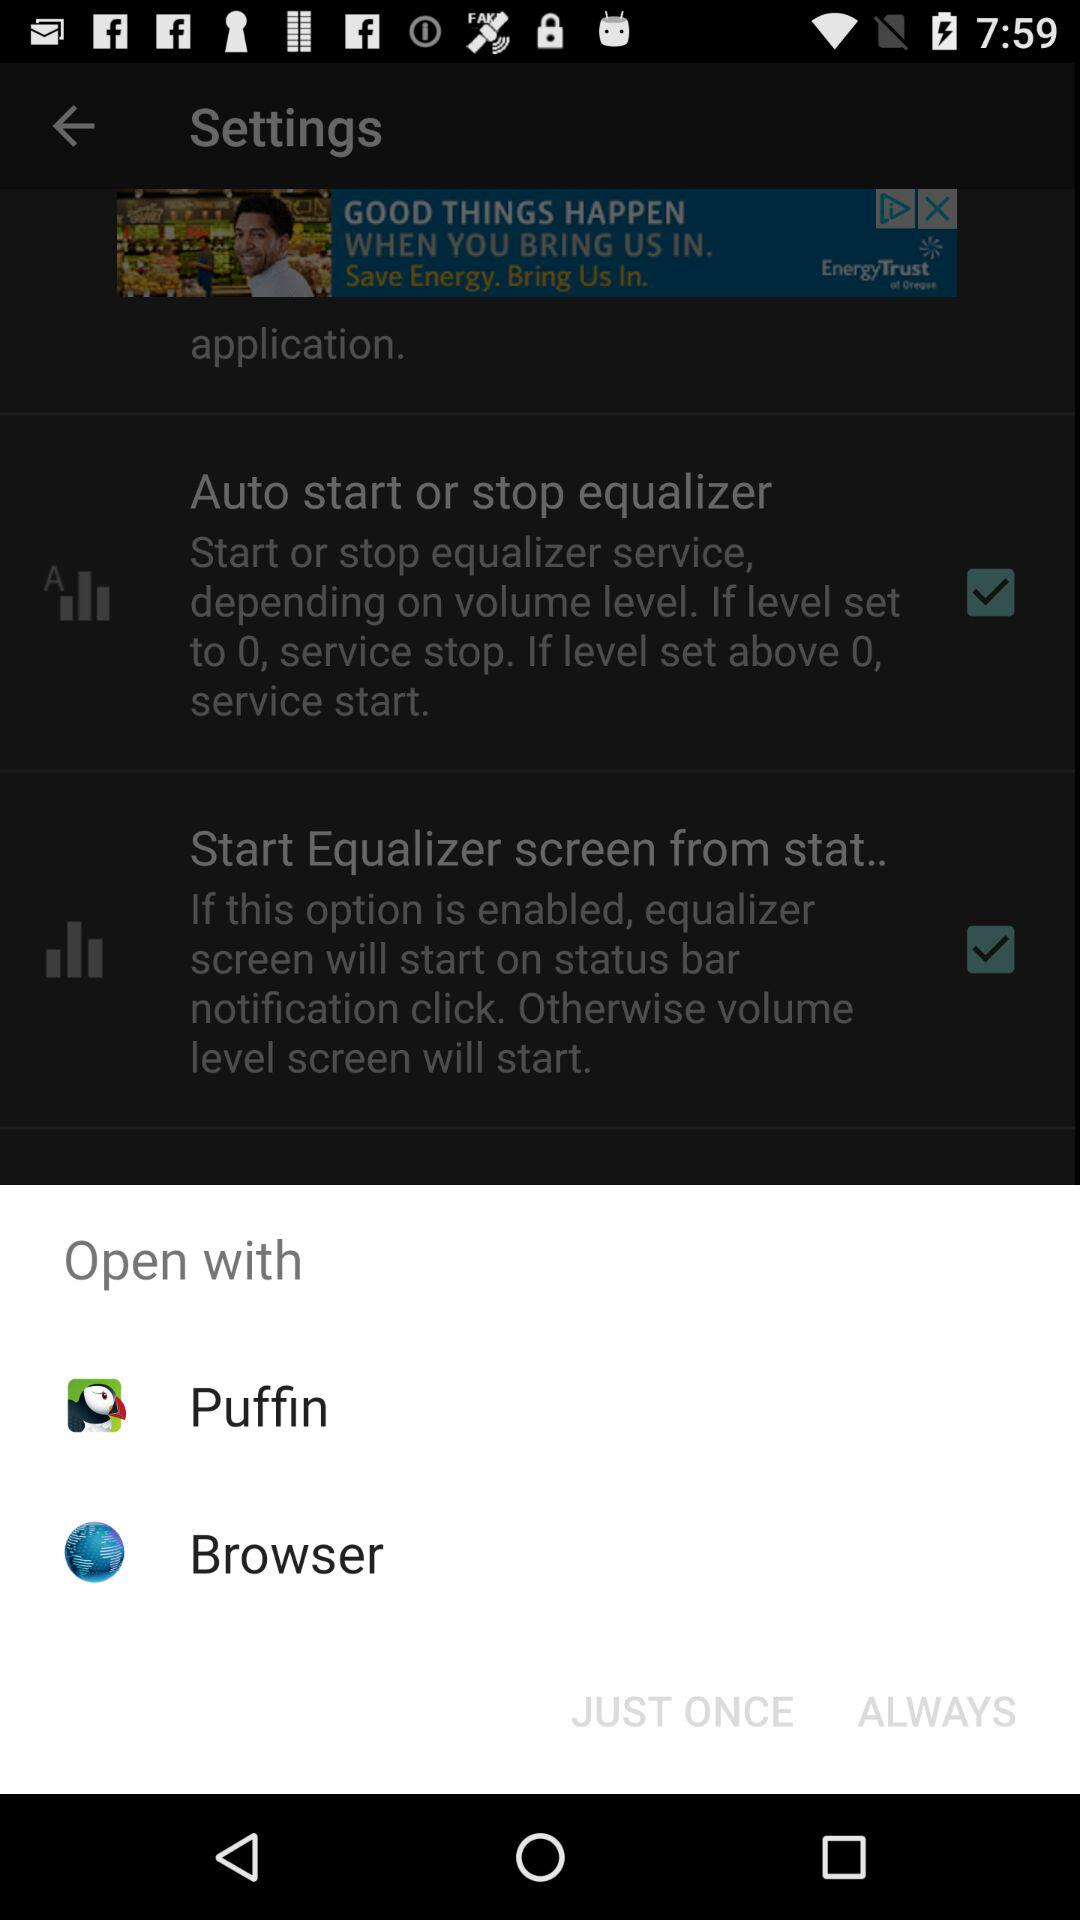How many check boxes are there in the settings section?
Answer the question using a single word or phrase. 2 